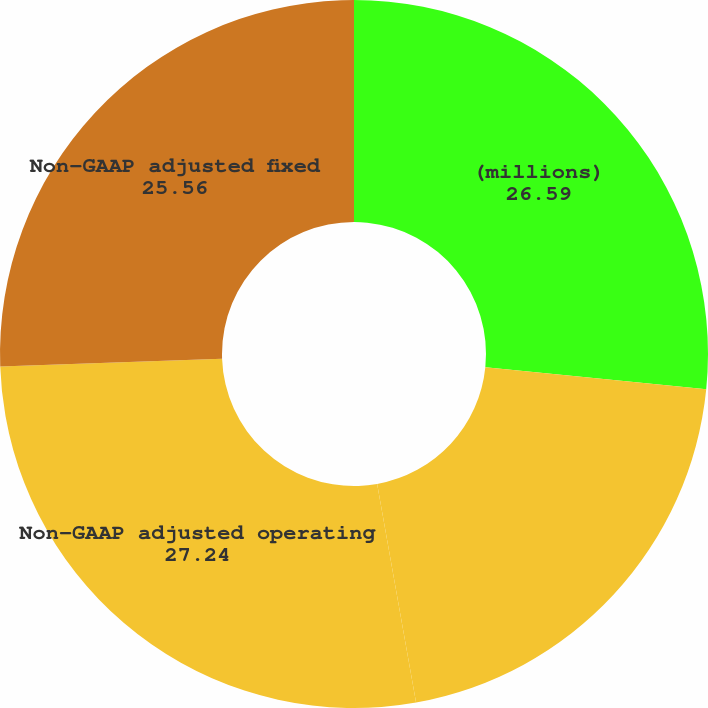Convert chart. <chart><loc_0><loc_0><loc_500><loc_500><pie_chart><fcel>(millions)<fcel>Reported GAAP operating income<fcel>Non-GAAP adjusted operating<fcel>Non-GAAP adjusted fixed<nl><fcel>26.59%<fcel>20.6%<fcel>27.24%<fcel>25.56%<nl></chart> 